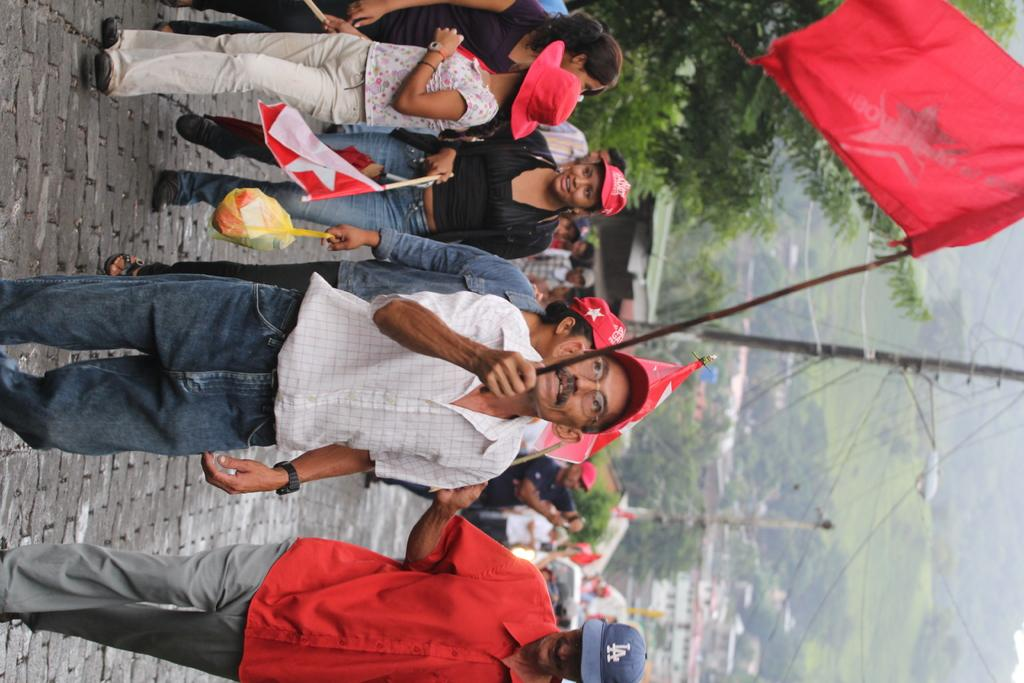What are the people in the image doing? The people in the image are walking on the road. What are some of the people holding? Some of the people are holding flags. What can be seen in the background of the image? There are trees, poles with wires, and buildings in the background of the image. What type of chin can be seen on the lawyer holding a bean in the image? There is no lawyer, bean, or chin present in the image. 